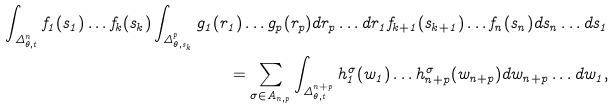<formula> <loc_0><loc_0><loc_500><loc_500>\int _ { \Delta _ { \theta , t } ^ { n } } f _ { 1 } ( s _ { 1 } ) \dots f _ { k } ( s _ { k } ) \int _ { \Delta _ { \theta , s _ { k } } ^ { p } } g _ { 1 } ( r _ { 1 } ) \dots g _ { p } ( r _ { p } ) d r _ { p } \dots d r _ { 1 } f _ { k + 1 } ( s _ { k + 1 } ) \dots f _ { n } ( s _ { n } ) d s _ { n } \dots d s _ { 1 } \\ = \sum _ { \sigma \in A _ { n , p } } \int _ { \Delta _ { \theta , t } ^ { n + p } } h ^ { \sigma } _ { 1 } ( w _ { 1 } ) \dots h ^ { \sigma } _ { n + p } ( w _ { n + p } ) d w _ { n + p } \dots d w _ { 1 } ,</formula> 